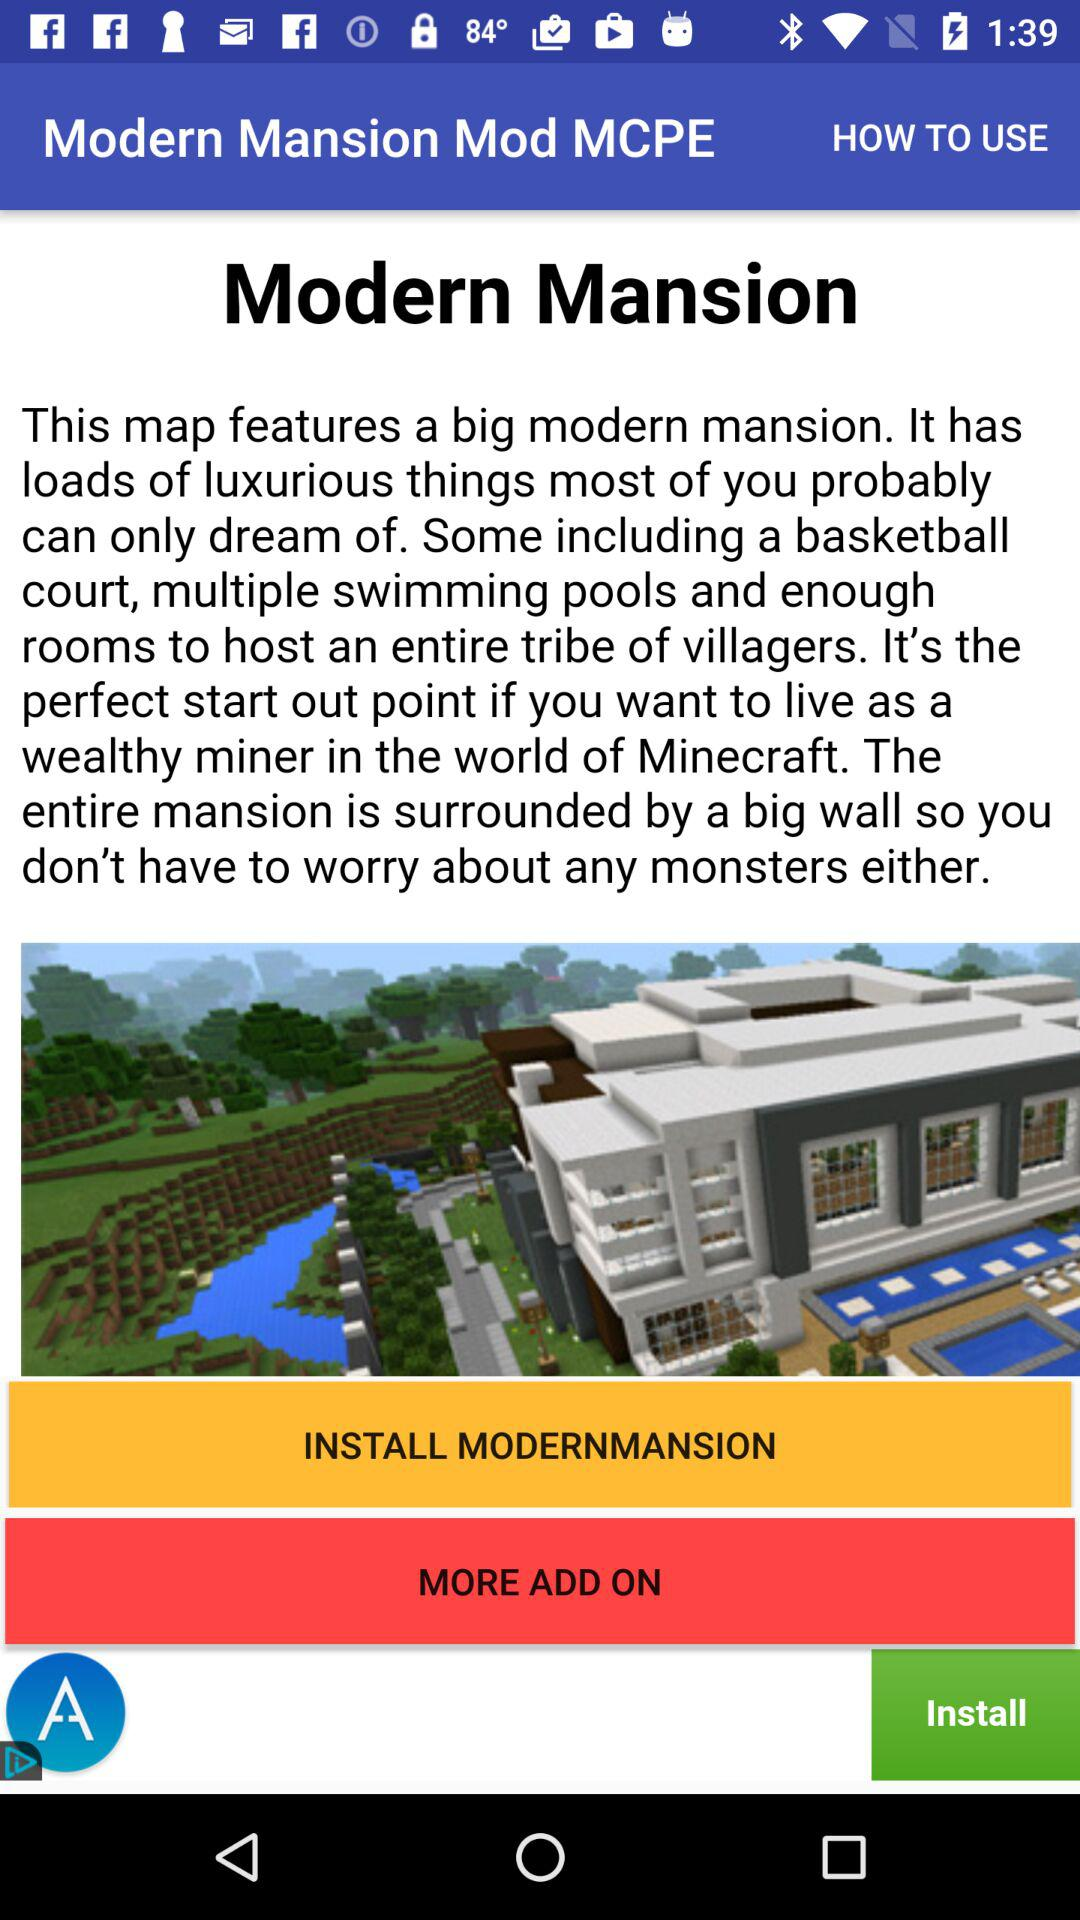How many add-ons are there?
When the provided information is insufficient, respond with <no answer>. <no answer> 